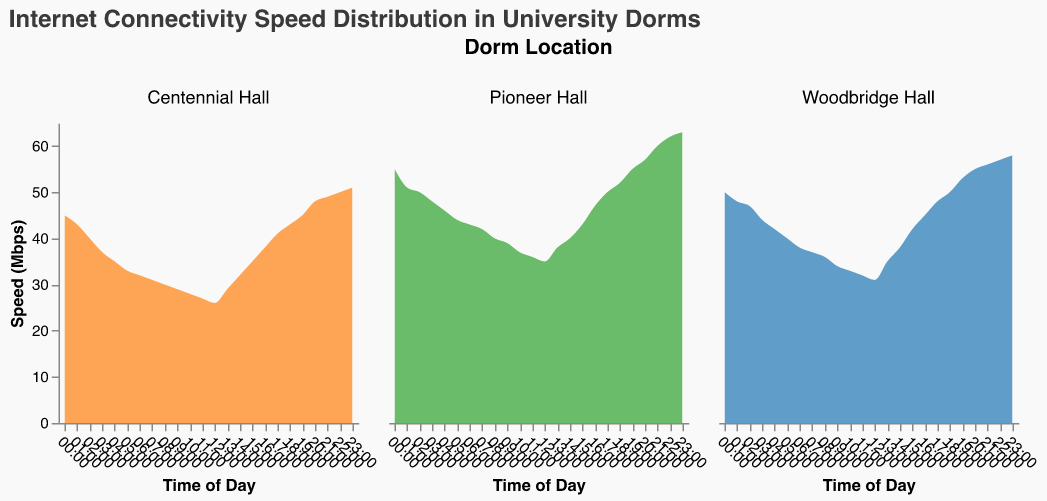What is the title of the figure? The title is usually found at the top of the figure and summarizes the content of the chart, providing an overview of what information is being presented.
Answer: Internet Connectivity Speed Distribution in University Dorms What time of day has the highest internet speed in Pioneer Hall? To find the highest internet speed in Pioneer Hall, look for the time of day where the area plot reaches its peak value.
Answer: 23:00 At what time does Centennial Hall experience the lowest internet speed? Identify the time where the internet speed plot for Centennial Hall is at its lowest point.
Answer: 08:00 Which dorm has the highest internet speed at 20:00? Compare the internet speed values of all dorms at 20:00 and identify the maximum value.
Answer: Pioneer Hall How does the internet speed in Woodbridge Hall at 06:00 compare to that in Pioneer Hall at the same time? Look at the internet speed values for both halls at 06:00 and analyze how they differ.
Answer: Woodbridge Hall is slower During which time periods does Centennial Hall's internet speed increase steadily? Identify the range of times where the speed plot for Centennial Hall is continuously rising without dips.
Answer: From 08:00 to 23:00 Which dorm shows the greatest fluctuation in internet speed throughout the day? Compare the range of speeds for each dorm by observing the highest and lowest points of the area plots to determine which has the widest range.
Answer: Woodbridge Hall What general trend can you identify for internet speed in all dorms from midnight to noon? Analyze the overall trend in the area plots for all dorms from 00:00 to 12:00 and note any consistent patterns.
Answer: Decreasing How do the internet speeds compare between Woodbridge Hall and Centennial Hall at 17:00? Look at the internet speed values for both halls at 17:00 and juxtapose them to see which is higher.
Answer: Woodbridge Hall is faster What is the range of internet speeds in Pioneer Hall between 12:00 and 15:00? Identify and compare the highest and lowest points on the area plot for Pioneer Hall between 12:00 and 15:00 to find the range.
Answer: 35 - 43 Mbps 